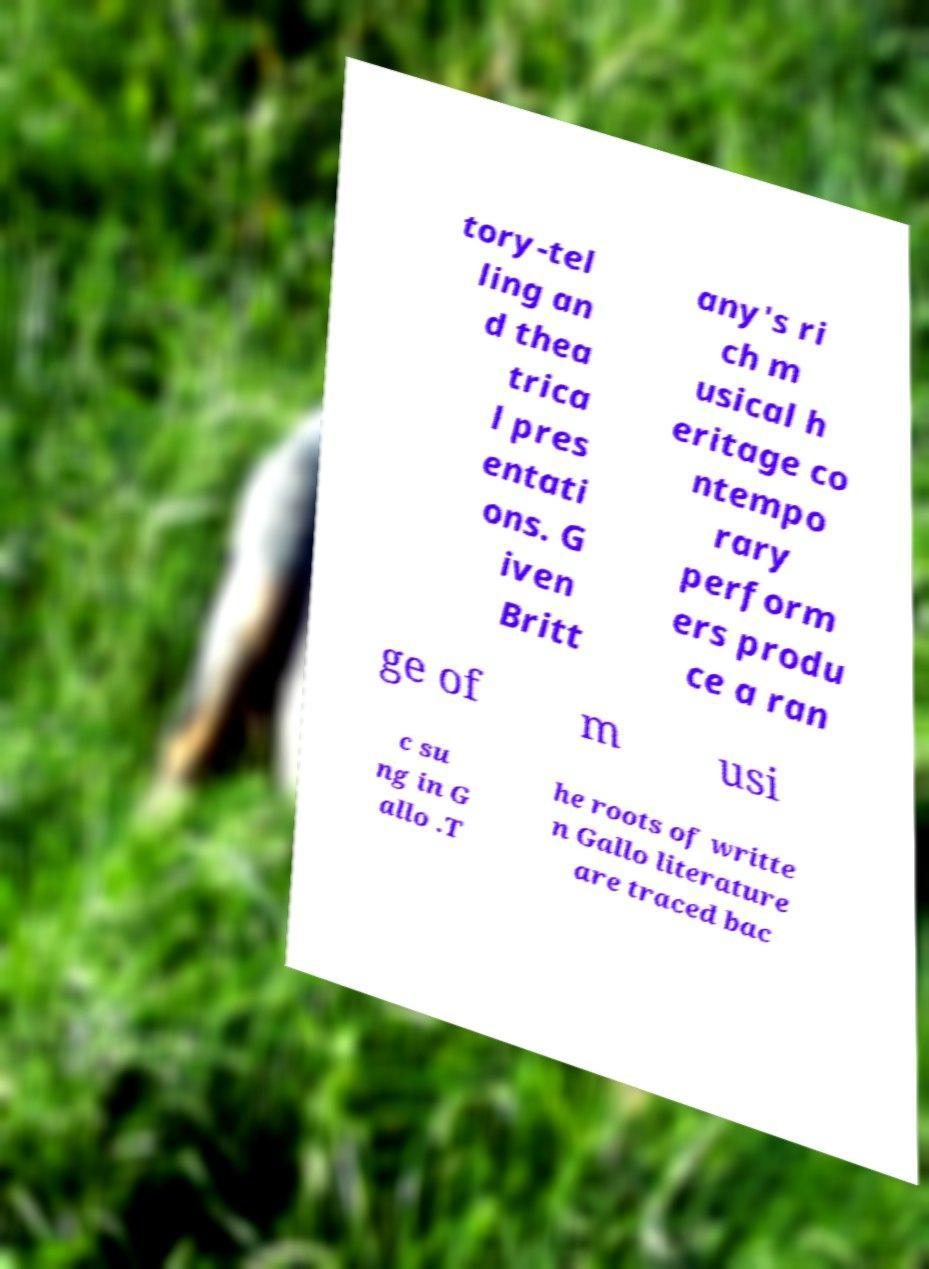Please read and relay the text visible in this image. What does it say? tory-tel ling an d thea trica l pres entati ons. G iven Britt any's ri ch m usical h eritage co ntempo rary perform ers produ ce a ran ge of m usi c su ng in G allo .T he roots of writte n Gallo literature are traced bac 